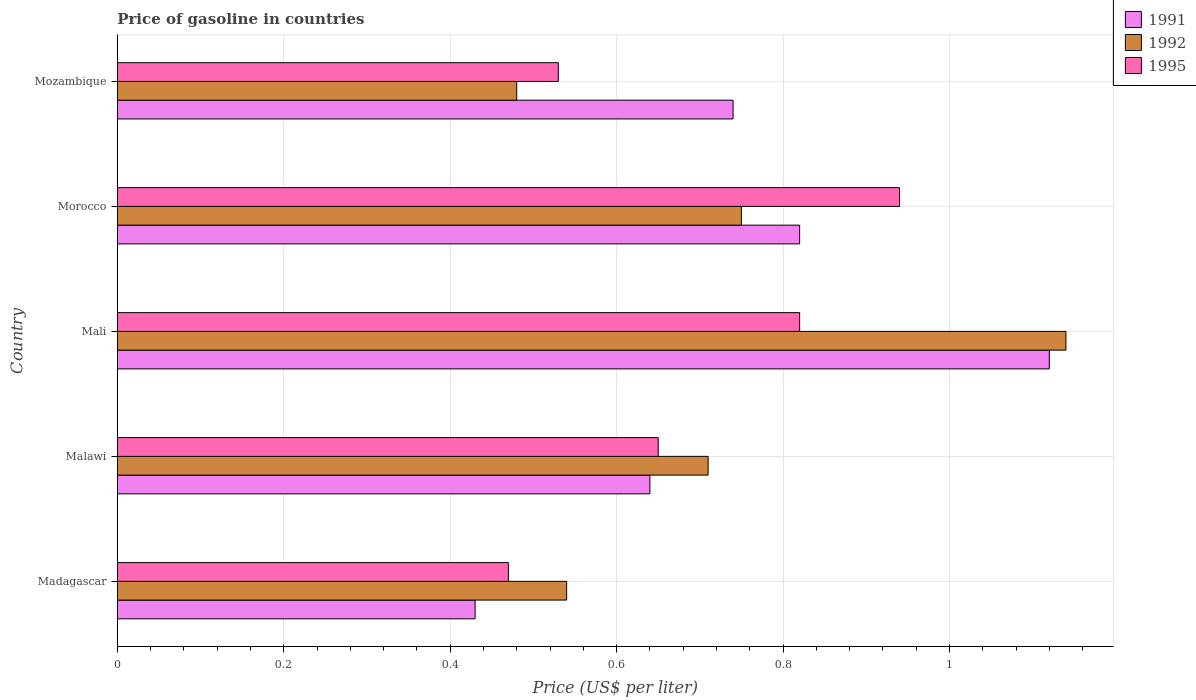Are the number of bars per tick equal to the number of legend labels?
Keep it short and to the point. Yes. How many bars are there on the 3rd tick from the bottom?
Your response must be concise. 3. What is the label of the 3rd group of bars from the top?
Keep it short and to the point. Mali. What is the price of gasoline in 1992 in Malawi?
Provide a short and direct response. 0.71. Across all countries, what is the maximum price of gasoline in 1992?
Ensure brevity in your answer.  1.14. Across all countries, what is the minimum price of gasoline in 1995?
Your response must be concise. 0.47. In which country was the price of gasoline in 1995 maximum?
Keep it short and to the point. Morocco. In which country was the price of gasoline in 1991 minimum?
Keep it short and to the point. Madagascar. What is the total price of gasoline in 1991 in the graph?
Offer a very short reply. 3.75. What is the difference between the price of gasoline in 1992 in Madagascar and that in Morocco?
Ensure brevity in your answer.  -0.21. What is the difference between the price of gasoline in 1992 in Madagascar and the price of gasoline in 1995 in Mali?
Offer a terse response. -0.28. What is the average price of gasoline in 1992 per country?
Your response must be concise. 0.72. What is the difference between the price of gasoline in 1991 and price of gasoline in 1992 in Morocco?
Keep it short and to the point. 0.07. In how many countries, is the price of gasoline in 1992 greater than 0.32 US$?
Offer a very short reply. 5. What is the ratio of the price of gasoline in 1995 in Mali to that in Mozambique?
Your answer should be compact. 1.55. Is the difference between the price of gasoline in 1991 in Madagascar and Mali greater than the difference between the price of gasoline in 1992 in Madagascar and Mali?
Provide a succinct answer. No. What is the difference between the highest and the second highest price of gasoline in 1991?
Offer a very short reply. 0.3. What is the difference between the highest and the lowest price of gasoline in 1991?
Your response must be concise. 0.69. Is the sum of the price of gasoline in 1992 in Malawi and Mali greater than the maximum price of gasoline in 1991 across all countries?
Keep it short and to the point. Yes. Are all the bars in the graph horizontal?
Offer a terse response. Yes. How many countries are there in the graph?
Keep it short and to the point. 5. What is the difference between two consecutive major ticks on the X-axis?
Offer a terse response. 0.2. Does the graph contain any zero values?
Ensure brevity in your answer.  No. How many legend labels are there?
Keep it short and to the point. 3. What is the title of the graph?
Offer a very short reply. Price of gasoline in countries. What is the label or title of the X-axis?
Keep it short and to the point. Price (US$ per liter). What is the label or title of the Y-axis?
Keep it short and to the point. Country. What is the Price (US$ per liter) in 1991 in Madagascar?
Your response must be concise. 0.43. What is the Price (US$ per liter) in 1992 in Madagascar?
Ensure brevity in your answer.  0.54. What is the Price (US$ per liter) in 1995 in Madagascar?
Your response must be concise. 0.47. What is the Price (US$ per liter) in 1991 in Malawi?
Provide a short and direct response. 0.64. What is the Price (US$ per liter) in 1992 in Malawi?
Your answer should be compact. 0.71. What is the Price (US$ per liter) of 1995 in Malawi?
Offer a very short reply. 0.65. What is the Price (US$ per liter) of 1991 in Mali?
Make the answer very short. 1.12. What is the Price (US$ per liter) in 1992 in Mali?
Offer a very short reply. 1.14. What is the Price (US$ per liter) in 1995 in Mali?
Your answer should be very brief. 0.82. What is the Price (US$ per liter) of 1991 in Morocco?
Your response must be concise. 0.82. What is the Price (US$ per liter) of 1992 in Morocco?
Your answer should be very brief. 0.75. What is the Price (US$ per liter) in 1995 in Morocco?
Your answer should be very brief. 0.94. What is the Price (US$ per liter) in 1991 in Mozambique?
Make the answer very short. 0.74. What is the Price (US$ per liter) in 1992 in Mozambique?
Offer a very short reply. 0.48. What is the Price (US$ per liter) in 1995 in Mozambique?
Ensure brevity in your answer.  0.53. Across all countries, what is the maximum Price (US$ per liter) of 1991?
Your answer should be very brief. 1.12. Across all countries, what is the maximum Price (US$ per liter) in 1992?
Your response must be concise. 1.14. Across all countries, what is the maximum Price (US$ per liter) of 1995?
Offer a very short reply. 0.94. Across all countries, what is the minimum Price (US$ per liter) of 1991?
Give a very brief answer. 0.43. Across all countries, what is the minimum Price (US$ per liter) in 1992?
Your answer should be very brief. 0.48. Across all countries, what is the minimum Price (US$ per liter) in 1995?
Keep it short and to the point. 0.47. What is the total Price (US$ per liter) of 1991 in the graph?
Your answer should be compact. 3.75. What is the total Price (US$ per liter) of 1992 in the graph?
Offer a terse response. 3.62. What is the total Price (US$ per liter) in 1995 in the graph?
Your answer should be very brief. 3.41. What is the difference between the Price (US$ per liter) of 1991 in Madagascar and that in Malawi?
Keep it short and to the point. -0.21. What is the difference between the Price (US$ per liter) in 1992 in Madagascar and that in Malawi?
Your answer should be very brief. -0.17. What is the difference between the Price (US$ per liter) in 1995 in Madagascar and that in Malawi?
Your answer should be very brief. -0.18. What is the difference between the Price (US$ per liter) of 1991 in Madagascar and that in Mali?
Make the answer very short. -0.69. What is the difference between the Price (US$ per liter) in 1992 in Madagascar and that in Mali?
Offer a very short reply. -0.6. What is the difference between the Price (US$ per liter) of 1995 in Madagascar and that in Mali?
Make the answer very short. -0.35. What is the difference between the Price (US$ per liter) of 1991 in Madagascar and that in Morocco?
Offer a terse response. -0.39. What is the difference between the Price (US$ per liter) in 1992 in Madagascar and that in Morocco?
Make the answer very short. -0.21. What is the difference between the Price (US$ per liter) in 1995 in Madagascar and that in Morocco?
Provide a short and direct response. -0.47. What is the difference between the Price (US$ per liter) in 1991 in Madagascar and that in Mozambique?
Keep it short and to the point. -0.31. What is the difference between the Price (US$ per liter) in 1995 in Madagascar and that in Mozambique?
Your answer should be compact. -0.06. What is the difference between the Price (US$ per liter) of 1991 in Malawi and that in Mali?
Give a very brief answer. -0.48. What is the difference between the Price (US$ per liter) of 1992 in Malawi and that in Mali?
Keep it short and to the point. -0.43. What is the difference between the Price (US$ per liter) of 1995 in Malawi and that in Mali?
Your answer should be compact. -0.17. What is the difference between the Price (US$ per liter) of 1991 in Malawi and that in Morocco?
Your answer should be compact. -0.18. What is the difference between the Price (US$ per liter) in 1992 in Malawi and that in Morocco?
Offer a terse response. -0.04. What is the difference between the Price (US$ per liter) in 1995 in Malawi and that in Morocco?
Your answer should be compact. -0.29. What is the difference between the Price (US$ per liter) in 1992 in Malawi and that in Mozambique?
Keep it short and to the point. 0.23. What is the difference between the Price (US$ per liter) in 1995 in Malawi and that in Mozambique?
Give a very brief answer. 0.12. What is the difference between the Price (US$ per liter) in 1992 in Mali and that in Morocco?
Give a very brief answer. 0.39. What is the difference between the Price (US$ per liter) of 1995 in Mali and that in Morocco?
Give a very brief answer. -0.12. What is the difference between the Price (US$ per liter) of 1991 in Mali and that in Mozambique?
Offer a terse response. 0.38. What is the difference between the Price (US$ per liter) of 1992 in Mali and that in Mozambique?
Your answer should be compact. 0.66. What is the difference between the Price (US$ per liter) in 1995 in Mali and that in Mozambique?
Your answer should be compact. 0.29. What is the difference between the Price (US$ per liter) of 1992 in Morocco and that in Mozambique?
Provide a short and direct response. 0.27. What is the difference between the Price (US$ per liter) in 1995 in Morocco and that in Mozambique?
Your answer should be very brief. 0.41. What is the difference between the Price (US$ per liter) of 1991 in Madagascar and the Price (US$ per liter) of 1992 in Malawi?
Your answer should be compact. -0.28. What is the difference between the Price (US$ per liter) of 1991 in Madagascar and the Price (US$ per liter) of 1995 in Malawi?
Your answer should be compact. -0.22. What is the difference between the Price (US$ per liter) in 1992 in Madagascar and the Price (US$ per liter) in 1995 in Malawi?
Keep it short and to the point. -0.11. What is the difference between the Price (US$ per liter) in 1991 in Madagascar and the Price (US$ per liter) in 1992 in Mali?
Provide a succinct answer. -0.71. What is the difference between the Price (US$ per liter) in 1991 in Madagascar and the Price (US$ per liter) in 1995 in Mali?
Provide a short and direct response. -0.39. What is the difference between the Price (US$ per liter) in 1992 in Madagascar and the Price (US$ per liter) in 1995 in Mali?
Keep it short and to the point. -0.28. What is the difference between the Price (US$ per liter) in 1991 in Madagascar and the Price (US$ per liter) in 1992 in Morocco?
Keep it short and to the point. -0.32. What is the difference between the Price (US$ per liter) in 1991 in Madagascar and the Price (US$ per liter) in 1995 in Morocco?
Your answer should be compact. -0.51. What is the difference between the Price (US$ per liter) of 1992 in Madagascar and the Price (US$ per liter) of 1995 in Morocco?
Give a very brief answer. -0.4. What is the difference between the Price (US$ per liter) in 1991 in Madagascar and the Price (US$ per liter) in 1995 in Mozambique?
Keep it short and to the point. -0.1. What is the difference between the Price (US$ per liter) of 1992 in Madagascar and the Price (US$ per liter) of 1995 in Mozambique?
Offer a very short reply. 0.01. What is the difference between the Price (US$ per liter) of 1991 in Malawi and the Price (US$ per liter) of 1995 in Mali?
Your response must be concise. -0.18. What is the difference between the Price (US$ per liter) of 1992 in Malawi and the Price (US$ per liter) of 1995 in Mali?
Provide a short and direct response. -0.11. What is the difference between the Price (US$ per liter) of 1991 in Malawi and the Price (US$ per liter) of 1992 in Morocco?
Make the answer very short. -0.11. What is the difference between the Price (US$ per liter) of 1991 in Malawi and the Price (US$ per liter) of 1995 in Morocco?
Your response must be concise. -0.3. What is the difference between the Price (US$ per liter) of 1992 in Malawi and the Price (US$ per liter) of 1995 in Morocco?
Your answer should be compact. -0.23. What is the difference between the Price (US$ per liter) in 1991 in Malawi and the Price (US$ per liter) in 1992 in Mozambique?
Give a very brief answer. 0.16. What is the difference between the Price (US$ per liter) of 1991 in Malawi and the Price (US$ per liter) of 1995 in Mozambique?
Provide a succinct answer. 0.11. What is the difference between the Price (US$ per liter) in 1992 in Malawi and the Price (US$ per liter) in 1995 in Mozambique?
Provide a succinct answer. 0.18. What is the difference between the Price (US$ per liter) in 1991 in Mali and the Price (US$ per liter) in 1992 in Morocco?
Give a very brief answer. 0.37. What is the difference between the Price (US$ per liter) of 1991 in Mali and the Price (US$ per liter) of 1995 in Morocco?
Offer a terse response. 0.18. What is the difference between the Price (US$ per liter) in 1991 in Mali and the Price (US$ per liter) in 1992 in Mozambique?
Your response must be concise. 0.64. What is the difference between the Price (US$ per liter) of 1991 in Mali and the Price (US$ per liter) of 1995 in Mozambique?
Provide a succinct answer. 0.59. What is the difference between the Price (US$ per liter) in 1992 in Mali and the Price (US$ per liter) in 1995 in Mozambique?
Your answer should be very brief. 0.61. What is the difference between the Price (US$ per liter) of 1991 in Morocco and the Price (US$ per liter) of 1992 in Mozambique?
Provide a short and direct response. 0.34. What is the difference between the Price (US$ per liter) of 1991 in Morocco and the Price (US$ per liter) of 1995 in Mozambique?
Make the answer very short. 0.29. What is the difference between the Price (US$ per liter) in 1992 in Morocco and the Price (US$ per liter) in 1995 in Mozambique?
Keep it short and to the point. 0.22. What is the average Price (US$ per liter) of 1991 per country?
Give a very brief answer. 0.75. What is the average Price (US$ per liter) of 1992 per country?
Your answer should be compact. 0.72. What is the average Price (US$ per liter) of 1995 per country?
Give a very brief answer. 0.68. What is the difference between the Price (US$ per liter) of 1991 and Price (US$ per liter) of 1992 in Madagascar?
Provide a short and direct response. -0.11. What is the difference between the Price (US$ per liter) of 1991 and Price (US$ per liter) of 1995 in Madagascar?
Ensure brevity in your answer.  -0.04. What is the difference between the Price (US$ per liter) in 1992 and Price (US$ per liter) in 1995 in Madagascar?
Offer a very short reply. 0.07. What is the difference between the Price (US$ per liter) of 1991 and Price (US$ per liter) of 1992 in Malawi?
Your response must be concise. -0.07. What is the difference between the Price (US$ per liter) of 1991 and Price (US$ per liter) of 1995 in Malawi?
Keep it short and to the point. -0.01. What is the difference between the Price (US$ per liter) in 1992 and Price (US$ per liter) in 1995 in Malawi?
Provide a succinct answer. 0.06. What is the difference between the Price (US$ per liter) of 1991 and Price (US$ per liter) of 1992 in Mali?
Offer a very short reply. -0.02. What is the difference between the Price (US$ per liter) of 1991 and Price (US$ per liter) of 1995 in Mali?
Offer a very short reply. 0.3. What is the difference between the Price (US$ per liter) of 1992 and Price (US$ per liter) of 1995 in Mali?
Keep it short and to the point. 0.32. What is the difference between the Price (US$ per liter) in 1991 and Price (US$ per liter) in 1992 in Morocco?
Make the answer very short. 0.07. What is the difference between the Price (US$ per liter) of 1991 and Price (US$ per liter) of 1995 in Morocco?
Your response must be concise. -0.12. What is the difference between the Price (US$ per liter) of 1992 and Price (US$ per liter) of 1995 in Morocco?
Give a very brief answer. -0.19. What is the difference between the Price (US$ per liter) of 1991 and Price (US$ per liter) of 1992 in Mozambique?
Provide a succinct answer. 0.26. What is the difference between the Price (US$ per liter) in 1991 and Price (US$ per liter) in 1995 in Mozambique?
Provide a succinct answer. 0.21. What is the ratio of the Price (US$ per liter) in 1991 in Madagascar to that in Malawi?
Your answer should be very brief. 0.67. What is the ratio of the Price (US$ per liter) of 1992 in Madagascar to that in Malawi?
Give a very brief answer. 0.76. What is the ratio of the Price (US$ per liter) in 1995 in Madagascar to that in Malawi?
Make the answer very short. 0.72. What is the ratio of the Price (US$ per liter) in 1991 in Madagascar to that in Mali?
Offer a very short reply. 0.38. What is the ratio of the Price (US$ per liter) in 1992 in Madagascar to that in Mali?
Provide a short and direct response. 0.47. What is the ratio of the Price (US$ per liter) of 1995 in Madagascar to that in Mali?
Keep it short and to the point. 0.57. What is the ratio of the Price (US$ per liter) of 1991 in Madagascar to that in Morocco?
Provide a short and direct response. 0.52. What is the ratio of the Price (US$ per liter) of 1992 in Madagascar to that in Morocco?
Make the answer very short. 0.72. What is the ratio of the Price (US$ per liter) in 1995 in Madagascar to that in Morocco?
Your response must be concise. 0.5. What is the ratio of the Price (US$ per liter) in 1991 in Madagascar to that in Mozambique?
Your response must be concise. 0.58. What is the ratio of the Price (US$ per liter) in 1995 in Madagascar to that in Mozambique?
Make the answer very short. 0.89. What is the ratio of the Price (US$ per liter) in 1991 in Malawi to that in Mali?
Provide a short and direct response. 0.57. What is the ratio of the Price (US$ per liter) of 1992 in Malawi to that in Mali?
Provide a succinct answer. 0.62. What is the ratio of the Price (US$ per liter) in 1995 in Malawi to that in Mali?
Give a very brief answer. 0.79. What is the ratio of the Price (US$ per liter) in 1991 in Malawi to that in Morocco?
Your answer should be compact. 0.78. What is the ratio of the Price (US$ per liter) in 1992 in Malawi to that in Morocco?
Keep it short and to the point. 0.95. What is the ratio of the Price (US$ per liter) in 1995 in Malawi to that in Morocco?
Offer a very short reply. 0.69. What is the ratio of the Price (US$ per liter) in 1991 in Malawi to that in Mozambique?
Offer a very short reply. 0.86. What is the ratio of the Price (US$ per liter) of 1992 in Malawi to that in Mozambique?
Give a very brief answer. 1.48. What is the ratio of the Price (US$ per liter) in 1995 in Malawi to that in Mozambique?
Keep it short and to the point. 1.23. What is the ratio of the Price (US$ per liter) of 1991 in Mali to that in Morocco?
Offer a terse response. 1.37. What is the ratio of the Price (US$ per liter) of 1992 in Mali to that in Morocco?
Ensure brevity in your answer.  1.52. What is the ratio of the Price (US$ per liter) in 1995 in Mali to that in Morocco?
Make the answer very short. 0.87. What is the ratio of the Price (US$ per liter) of 1991 in Mali to that in Mozambique?
Provide a succinct answer. 1.51. What is the ratio of the Price (US$ per liter) of 1992 in Mali to that in Mozambique?
Your answer should be compact. 2.38. What is the ratio of the Price (US$ per liter) of 1995 in Mali to that in Mozambique?
Your response must be concise. 1.55. What is the ratio of the Price (US$ per liter) of 1991 in Morocco to that in Mozambique?
Ensure brevity in your answer.  1.11. What is the ratio of the Price (US$ per liter) in 1992 in Morocco to that in Mozambique?
Give a very brief answer. 1.56. What is the ratio of the Price (US$ per liter) in 1995 in Morocco to that in Mozambique?
Your answer should be very brief. 1.77. What is the difference between the highest and the second highest Price (US$ per liter) in 1991?
Ensure brevity in your answer.  0.3. What is the difference between the highest and the second highest Price (US$ per liter) in 1992?
Give a very brief answer. 0.39. What is the difference between the highest and the second highest Price (US$ per liter) of 1995?
Provide a short and direct response. 0.12. What is the difference between the highest and the lowest Price (US$ per liter) of 1991?
Provide a succinct answer. 0.69. What is the difference between the highest and the lowest Price (US$ per liter) of 1992?
Keep it short and to the point. 0.66. What is the difference between the highest and the lowest Price (US$ per liter) of 1995?
Offer a terse response. 0.47. 